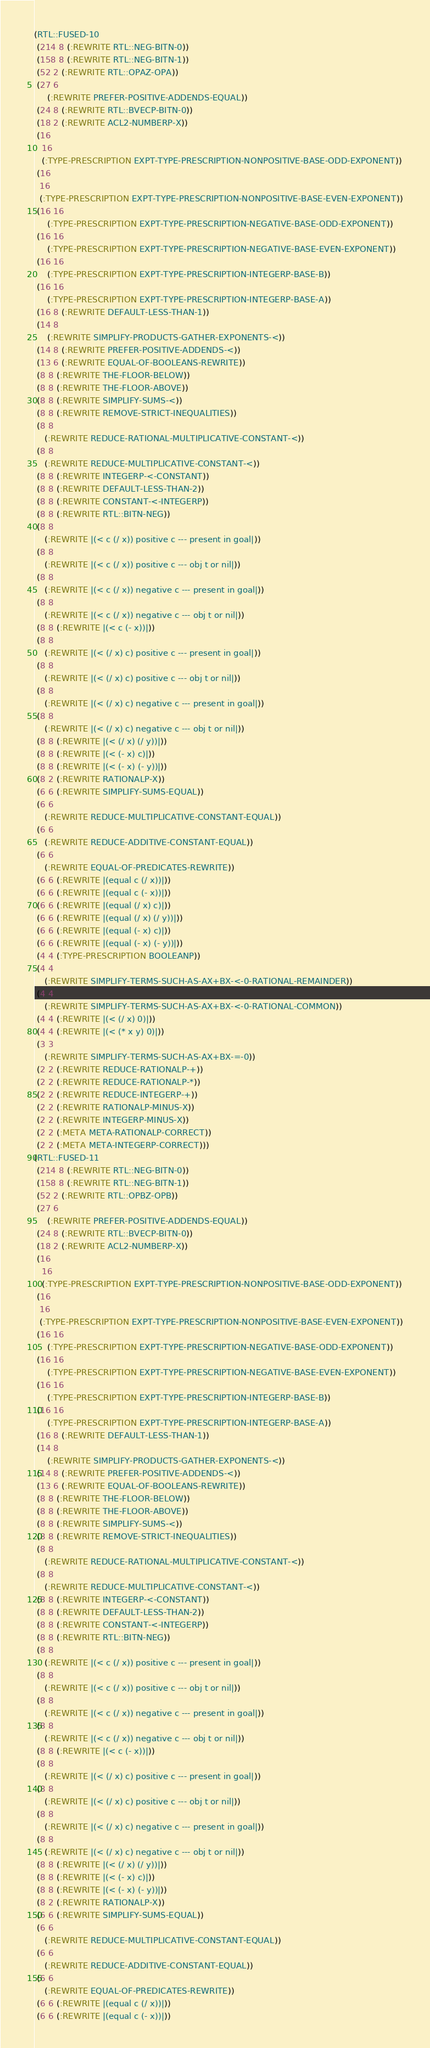Convert code to text. <code><loc_0><loc_0><loc_500><loc_500><_Lisp_>(RTL::FUSED-10
 (214 8 (:REWRITE RTL::NEG-BITN-0))
 (158 8 (:REWRITE RTL::NEG-BITN-1))
 (52 2 (:REWRITE RTL::OPAZ-OPA))
 (27 6
     (:REWRITE PREFER-POSITIVE-ADDENDS-EQUAL))
 (24 8 (:REWRITE RTL::BVECP-BITN-0))
 (18 2 (:REWRITE ACL2-NUMBERP-X))
 (16
   16
   (:TYPE-PRESCRIPTION EXPT-TYPE-PRESCRIPTION-NONPOSITIVE-BASE-ODD-EXPONENT))
 (16
  16
  (:TYPE-PRESCRIPTION EXPT-TYPE-PRESCRIPTION-NONPOSITIVE-BASE-EVEN-EXPONENT))
 (16 16
     (:TYPE-PRESCRIPTION EXPT-TYPE-PRESCRIPTION-NEGATIVE-BASE-ODD-EXPONENT))
 (16 16
     (:TYPE-PRESCRIPTION EXPT-TYPE-PRESCRIPTION-NEGATIVE-BASE-EVEN-EXPONENT))
 (16 16
     (:TYPE-PRESCRIPTION EXPT-TYPE-PRESCRIPTION-INTEGERP-BASE-B))
 (16 16
     (:TYPE-PRESCRIPTION EXPT-TYPE-PRESCRIPTION-INTEGERP-BASE-A))
 (16 8 (:REWRITE DEFAULT-LESS-THAN-1))
 (14 8
     (:REWRITE SIMPLIFY-PRODUCTS-GATHER-EXPONENTS-<))
 (14 8 (:REWRITE PREFER-POSITIVE-ADDENDS-<))
 (13 6 (:REWRITE EQUAL-OF-BOOLEANS-REWRITE))
 (8 8 (:REWRITE THE-FLOOR-BELOW))
 (8 8 (:REWRITE THE-FLOOR-ABOVE))
 (8 8 (:REWRITE SIMPLIFY-SUMS-<))
 (8 8 (:REWRITE REMOVE-STRICT-INEQUALITIES))
 (8 8
    (:REWRITE REDUCE-RATIONAL-MULTIPLICATIVE-CONSTANT-<))
 (8 8
    (:REWRITE REDUCE-MULTIPLICATIVE-CONSTANT-<))
 (8 8 (:REWRITE INTEGERP-<-CONSTANT))
 (8 8 (:REWRITE DEFAULT-LESS-THAN-2))
 (8 8 (:REWRITE CONSTANT-<-INTEGERP))
 (8 8 (:REWRITE RTL::BITN-NEG))
 (8 8
    (:REWRITE |(< c (/ x)) positive c --- present in goal|))
 (8 8
    (:REWRITE |(< c (/ x)) positive c --- obj t or nil|))
 (8 8
    (:REWRITE |(< c (/ x)) negative c --- present in goal|))
 (8 8
    (:REWRITE |(< c (/ x)) negative c --- obj t or nil|))
 (8 8 (:REWRITE |(< c (- x))|))
 (8 8
    (:REWRITE |(< (/ x) c) positive c --- present in goal|))
 (8 8
    (:REWRITE |(< (/ x) c) positive c --- obj t or nil|))
 (8 8
    (:REWRITE |(< (/ x) c) negative c --- present in goal|))
 (8 8
    (:REWRITE |(< (/ x) c) negative c --- obj t or nil|))
 (8 8 (:REWRITE |(< (/ x) (/ y))|))
 (8 8 (:REWRITE |(< (- x) c)|))
 (8 8 (:REWRITE |(< (- x) (- y))|))
 (8 2 (:REWRITE RATIONALP-X))
 (6 6 (:REWRITE SIMPLIFY-SUMS-EQUAL))
 (6 6
    (:REWRITE REDUCE-MULTIPLICATIVE-CONSTANT-EQUAL))
 (6 6
    (:REWRITE REDUCE-ADDITIVE-CONSTANT-EQUAL))
 (6 6
    (:REWRITE EQUAL-OF-PREDICATES-REWRITE))
 (6 6 (:REWRITE |(equal c (/ x))|))
 (6 6 (:REWRITE |(equal c (- x))|))
 (6 6 (:REWRITE |(equal (/ x) c)|))
 (6 6 (:REWRITE |(equal (/ x) (/ y))|))
 (6 6 (:REWRITE |(equal (- x) c)|))
 (6 6 (:REWRITE |(equal (- x) (- y))|))
 (4 4 (:TYPE-PRESCRIPTION BOOLEANP))
 (4 4
    (:REWRITE SIMPLIFY-TERMS-SUCH-AS-AX+BX-<-0-RATIONAL-REMAINDER))
 (4 4
    (:REWRITE SIMPLIFY-TERMS-SUCH-AS-AX+BX-<-0-RATIONAL-COMMON))
 (4 4 (:REWRITE |(< (/ x) 0)|))
 (4 4 (:REWRITE |(< (* x y) 0)|))
 (3 3
    (:REWRITE SIMPLIFY-TERMS-SUCH-AS-AX+BX-=-0))
 (2 2 (:REWRITE REDUCE-RATIONALP-+))
 (2 2 (:REWRITE REDUCE-RATIONALP-*))
 (2 2 (:REWRITE REDUCE-INTEGERP-+))
 (2 2 (:REWRITE RATIONALP-MINUS-X))
 (2 2 (:REWRITE INTEGERP-MINUS-X))
 (2 2 (:META META-RATIONALP-CORRECT))
 (2 2 (:META META-INTEGERP-CORRECT)))
(RTL::FUSED-11
 (214 8 (:REWRITE RTL::NEG-BITN-0))
 (158 8 (:REWRITE RTL::NEG-BITN-1))
 (52 2 (:REWRITE RTL::OPBZ-OPB))
 (27 6
     (:REWRITE PREFER-POSITIVE-ADDENDS-EQUAL))
 (24 8 (:REWRITE RTL::BVECP-BITN-0))
 (18 2 (:REWRITE ACL2-NUMBERP-X))
 (16
   16
   (:TYPE-PRESCRIPTION EXPT-TYPE-PRESCRIPTION-NONPOSITIVE-BASE-ODD-EXPONENT))
 (16
  16
  (:TYPE-PRESCRIPTION EXPT-TYPE-PRESCRIPTION-NONPOSITIVE-BASE-EVEN-EXPONENT))
 (16 16
     (:TYPE-PRESCRIPTION EXPT-TYPE-PRESCRIPTION-NEGATIVE-BASE-ODD-EXPONENT))
 (16 16
     (:TYPE-PRESCRIPTION EXPT-TYPE-PRESCRIPTION-NEGATIVE-BASE-EVEN-EXPONENT))
 (16 16
     (:TYPE-PRESCRIPTION EXPT-TYPE-PRESCRIPTION-INTEGERP-BASE-B))
 (16 16
     (:TYPE-PRESCRIPTION EXPT-TYPE-PRESCRIPTION-INTEGERP-BASE-A))
 (16 8 (:REWRITE DEFAULT-LESS-THAN-1))
 (14 8
     (:REWRITE SIMPLIFY-PRODUCTS-GATHER-EXPONENTS-<))
 (14 8 (:REWRITE PREFER-POSITIVE-ADDENDS-<))
 (13 6 (:REWRITE EQUAL-OF-BOOLEANS-REWRITE))
 (8 8 (:REWRITE THE-FLOOR-BELOW))
 (8 8 (:REWRITE THE-FLOOR-ABOVE))
 (8 8 (:REWRITE SIMPLIFY-SUMS-<))
 (8 8 (:REWRITE REMOVE-STRICT-INEQUALITIES))
 (8 8
    (:REWRITE REDUCE-RATIONAL-MULTIPLICATIVE-CONSTANT-<))
 (8 8
    (:REWRITE REDUCE-MULTIPLICATIVE-CONSTANT-<))
 (8 8 (:REWRITE INTEGERP-<-CONSTANT))
 (8 8 (:REWRITE DEFAULT-LESS-THAN-2))
 (8 8 (:REWRITE CONSTANT-<-INTEGERP))
 (8 8 (:REWRITE RTL::BITN-NEG))
 (8 8
    (:REWRITE |(< c (/ x)) positive c --- present in goal|))
 (8 8
    (:REWRITE |(< c (/ x)) positive c --- obj t or nil|))
 (8 8
    (:REWRITE |(< c (/ x)) negative c --- present in goal|))
 (8 8
    (:REWRITE |(< c (/ x)) negative c --- obj t or nil|))
 (8 8 (:REWRITE |(< c (- x))|))
 (8 8
    (:REWRITE |(< (/ x) c) positive c --- present in goal|))
 (8 8
    (:REWRITE |(< (/ x) c) positive c --- obj t or nil|))
 (8 8
    (:REWRITE |(< (/ x) c) negative c --- present in goal|))
 (8 8
    (:REWRITE |(< (/ x) c) negative c --- obj t or nil|))
 (8 8 (:REWRITE |(< (/ x) (/ y))|))
 (8 8 (:REWRITE |(< (- x) c)|))
 (8 8 (:REWRITE |(< (- x) (- y))|))
 (8 2 (:REWRITE RATIONALP-X))
 (6 6 (:REWRITE SIMPLIFY-SUMS-EQUAL))
 (6 6
    (:REWRITE REDUCE-MULTIPLICATIVE-CONSTANT-EQUAL))
 (6 6
    (:REWRITE REDUCE-ADDITIVE-CONSTANT-EQUAL))
 (6 6
    (:REWRITE EQUAL-OF-PREDICATES-REWRITE))
 (6 6 (:REWRITE |(equal c (/ x))|))
 (6 6 (:REWRITE |(equal c (- x))|))</code> 